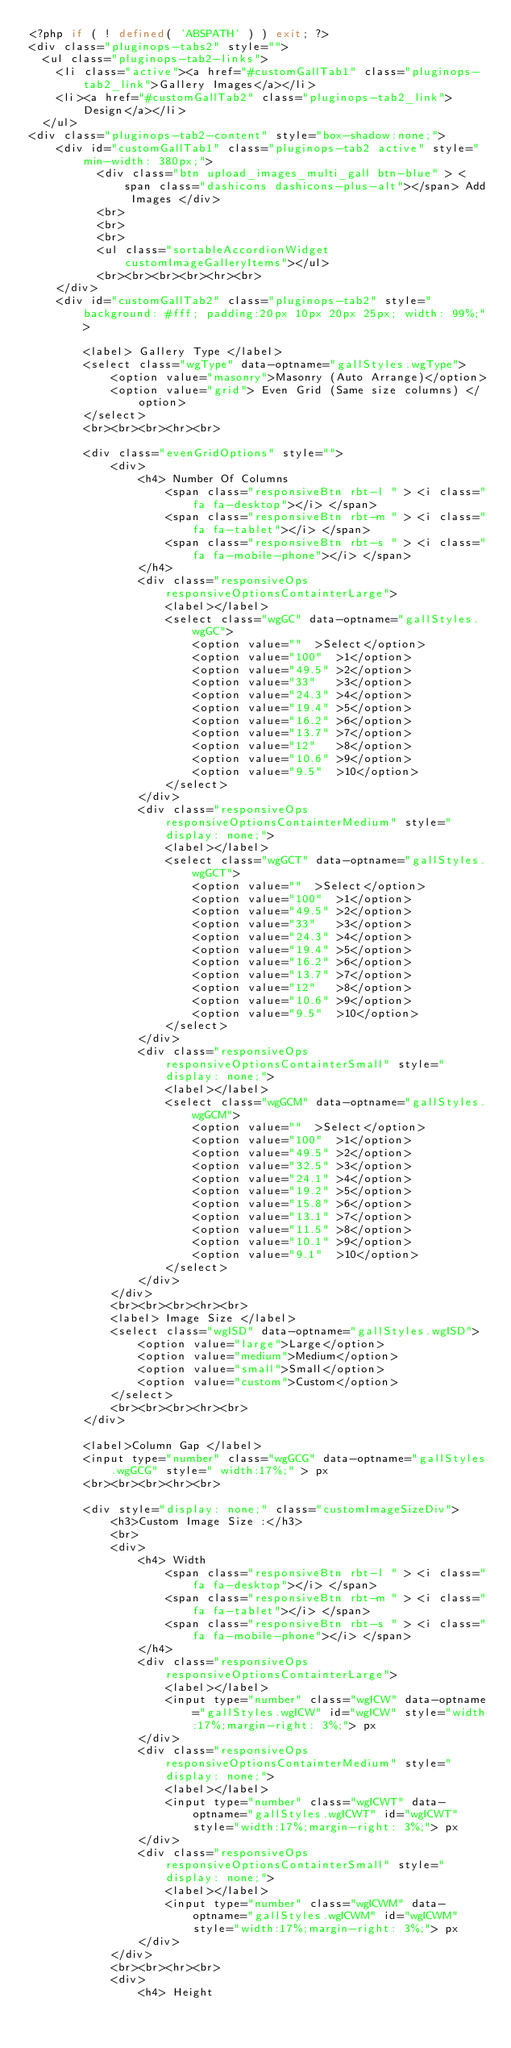<code> <loc_0><loc_0><loc_500><loc_500><_PHP_><?php if ( ! defined( 'ABSPATH' ) ) exit; ?>
<div class="pluginops-tabs2" style="">
  <ul class="pluginops-tab2-links">
    <li class="active"><a href="#customGallTab1" class="pluginops-tab2_link">Gallery Images</a></li>
    <li><a href="#customGallTab2" class="pluginops-tab2_link">Design</a></li>
  </ul>
<div class="pluginops-tab2-content" style="box-shadow:none;">
	<div id="customGallTab1" class="pluginops-tab2 active" style="min-width: 380px;">
		  <div class="btn upload_images_multi_gall btn-blue" > <span class="dashicons dashicons-plus-alt"></span> Add Images </div>
		  <br>
          <br>
          <br>
          <ul class="sortableAccordionWidget  customImageGalleryItems"></ul>
          <br><br><br><br><hr><br>
	</div>
	<div id="customGallTab2" class="pluginops-tab2" style="background: #fff; padding:20px 10px 20px 25px; width: 99%;">

		<label> Gallery Type </label>
		<select class="wgType" data-optname="gallStyles.wgType">
			<option value="masonry">Masonry (Auto Arrange)</option>
			<option value="grid"> Even Grid (Same size columns) </option>
		</select>
		<br><br><br><hr><br>

		<div class="evenGridOptions" style="">
			<div>
		      	<h4> Number Of Columns
		        	<span class="responsiveBtn rbt-l " > <i class="fa fa-desktop"></i> </span>   
		         	<span class="responsiveBtn rbt-m " > <i class="fa fa-tablet"></i> </span>
		         	<span class="responsiveBtn rbt-s " > <i class="fa fa-mobile-phone"></i> </span>
		      	</h4>
		      	<div class="responsiveOps responsiveOptionsContainterLarge">
		         	<label></label>
		         	<select class="wgGC" data-optname="gallStyles.wgGC">
		         		<option value=""  >Select</option>
						<option value="100"  >1</option>
						<option value="49.5" >2</option>
						<option value="33"   >3</option>
						<option value="24.3" >4</option>
						<option value="19.4" >5</option>
						<option value="16.2" >6</option>
						<option value="13.7" >7</option>
						<option value="12"   >8</option>
						<option value="10.6" >9</option>
						<option value="9.5"  >10</option>
					</select>
		      	</div>
		      	<div class="responsiveOps responsiveOptionsContainterMedium" style="display: none;">
		         	<label></label>
		         	<select class="wgGCT" data-optname="gallStyles.wgGCT">
						<option value=""  >Select</option>
						<option value="100"  >1</option>
						<option value="49.5" >2</option>
						<option value="33"   >3</option>
						<option value="24.3" >4</option>
						<option value="19.4" >5</option>
						<option value="16.2" >6</option>
						<option value="13.7" >7</option>
						<option value="12"   >8</option>
						<option value="10.6" >9</option>
						<option value="9.5"  >10</option>
					</select>
		      	</div>
		      	<div class="responsiveOps responsiveOptionsContainterSmall" style="display: none;">
		         	<label></label>
		         	<select class="wgGCM" data-optname="gallStyles.wgGCM">
		         		<option value=""  >Select</option>
						<option value="100"  >1</option>
						<option value="49.5" >2</option>
						<option value="32.5" >3</option>
						<option value="24.1" >4</option>
						<option value="19.2" >5</option>
						<option value="15.8" >6</option>
						<option value="13.1" >7</option>
						<option value="11.5" >8</option>
						<option value="10.1" >9</option>
						<option value="9.1"  >10</option>
					</select>
		      	</div>
		   	</div>
			<br><br><br><hr><br>
			<label> Image Size </label>
			<select class="wgISD" data-optname="gallStyles.wgISD">
		    	<option value="large">Large</option>
		    	<option value="medium">Medium</option>
		    	<option value="small">Small</option>
		    	<option value="custom">Custom</option>
			</select>
			<br><br><br><hr><br>
		</div>

		<label>Column Gap </label>
		<input type="number" class="wgGCG" data-optname="gallStyles.wgGCG" style=" width:17%;" > px
		<br><br><br><hr><br>

	   	<div style="display: none;" class="customImageSizeDiv">
		   	<h3>Custom Image Size :</h3>
		   	<br>
		   	<div>
		      	<h4> Width
		        	<span class="responsiveBtn rbt-l " > <i class="fa fa-desktop"></i> </span>   
		         	<span class="responsiveBtn rbt-m " > <i class="fa fa-tablet"></i> </span>
		         	<span class="responsiveBtn rbt-s " > <i class="fa fa-mobile-phone"></i> </span>
		      	</h4>
		      	<div class="responsiveOps responsiveOptionsContainterLarge">
		         	<label></label>
		         	<input type="number" class="wgICW" data-optname="gallStyles.wgICW" id="wgICW" style="width:17%;margin-right: 3%;"> px
		      	</div>
		      	<div class="responsiveOps responsiveOptionsContainterMedium" style="display: none;">
		         	<label></label>
		         	<input type="number" class="wgICWT" data-optname="gallStyles.wgICWT" id="wgICWT" style="width:17%;margin-right: 3%;"> px
		      	</div>
		      	<div class="responsiveOps responsiveOptionsContainterSmall" style="display: none;">
		         	<label></label>
		         	<input type="number" class="wgICWM" data-optname="gallStyles.wgICWM" id="wgICWM" style="width:17%;margin-right: 3%;"> px
		      	</div>
		   	</div>
		   	<br><br><hr><br>
		   	<div>
		      	<h4> Height</code> 